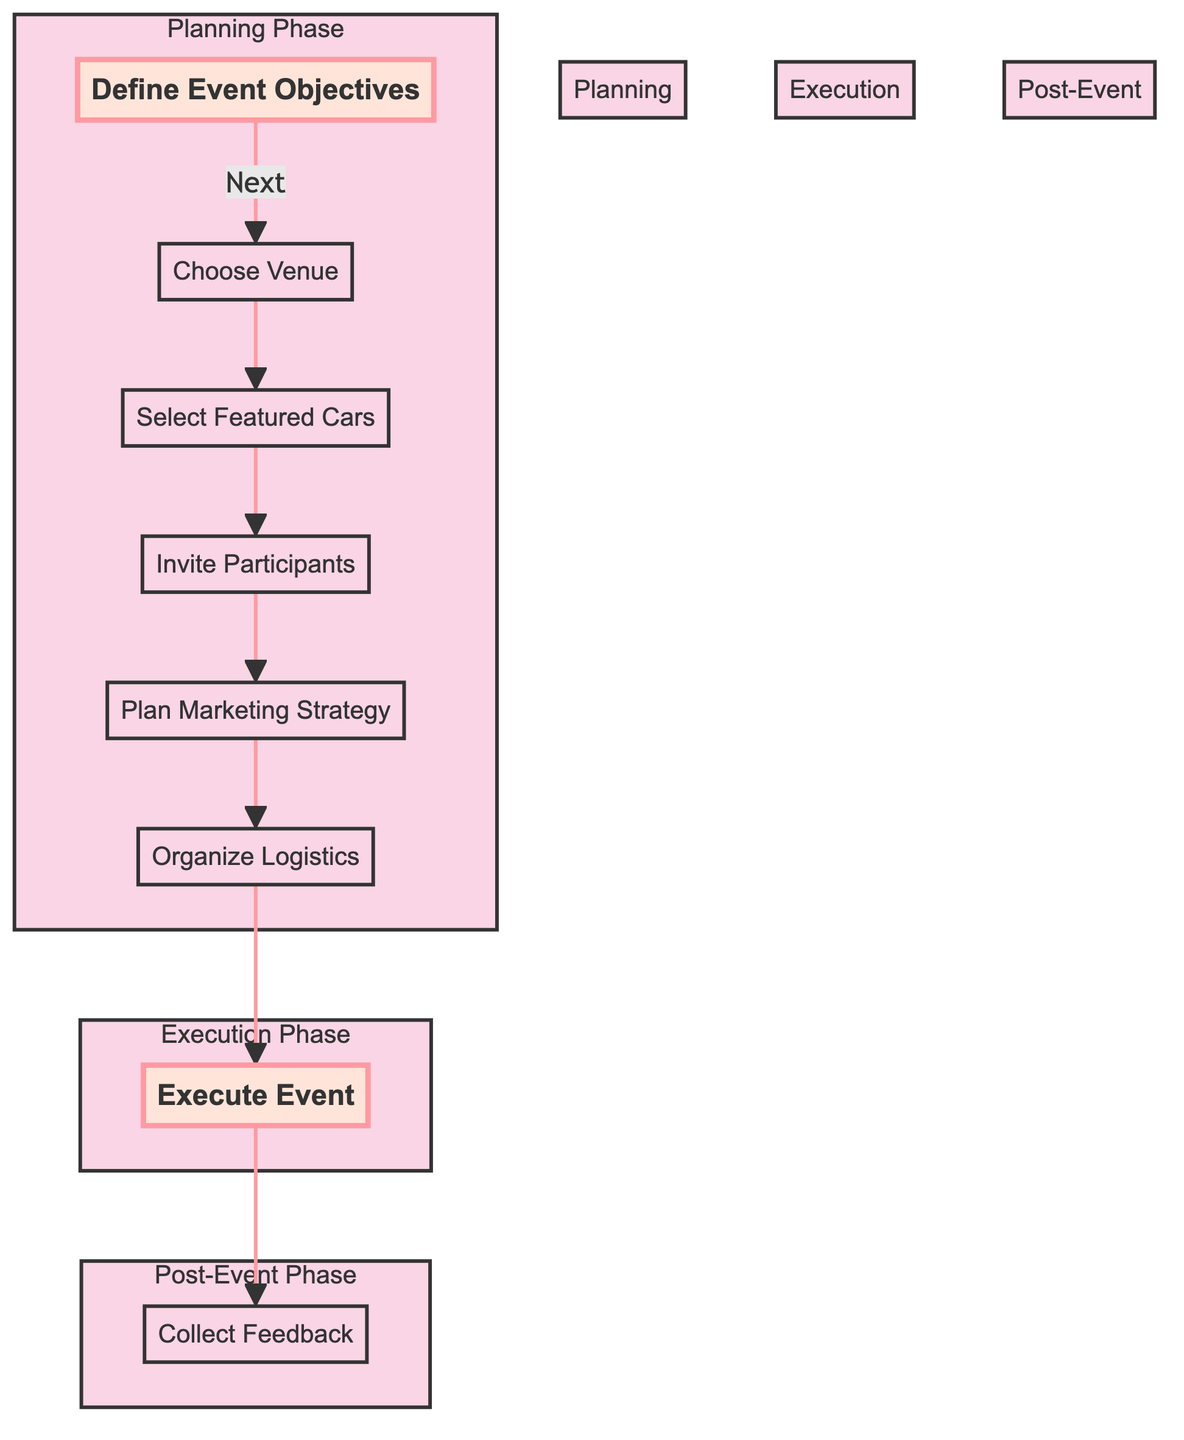What is the last step of the flow chart? The last step in the flow chart is indicated by the node "Collect Feedback," which is the final action after executing the event.
Answer: Collect Feedback How many main phases are there in the diagram? The diagram consists of three main phases: Planning Phase, Execution Phase, and Post-Event Phase, which can be counted based on how the nodes are grouped.
Answer: Three What is the first node in the flow chart? The first node is labeled "Define Event Objectives," which is the starting point of the showcase event planning process.
Answer: Define Event Objectives Which node comes after "Select Featured Cars"? The node that comes directly after "Select Featured Cars" is "Invite Participants," detailing the next action to take in the flow.
Answer: Invite Participants What phase includes the step "Organize Logistics"? The step "Organize Logistics" is part of the Planning Phase, which encompasses all the preliminary actions before the event execution.
Answer: Planning Phase How many nodes are there in the diagram? By counting all the individual steps represented in the flow chart, there are a total of eight nodes detailing different aspects of the event planning process.
Answer: Eight What type of participants are invited according to the flow chart? The flow chart specifies inviting "collectors, enthusiasts, and local businesses," indicating the types of participants targeted for the event.
Answer: Collectors, enthusiasts, and local businesses What is the main purpose of the "Plan Marketing Strategy" node? The purpose of the "Plan Marketing Strategy" node is to develop a promotional plan that leverages social media, flyers, and local news to attract attendees.
Answer: Promote the event Which phase is focused on hosting the event? The focus of hosting the event falls in the Execution Phase, with the step named "Execute Event" representing this specific action and context.
Answer: Execution Phase 